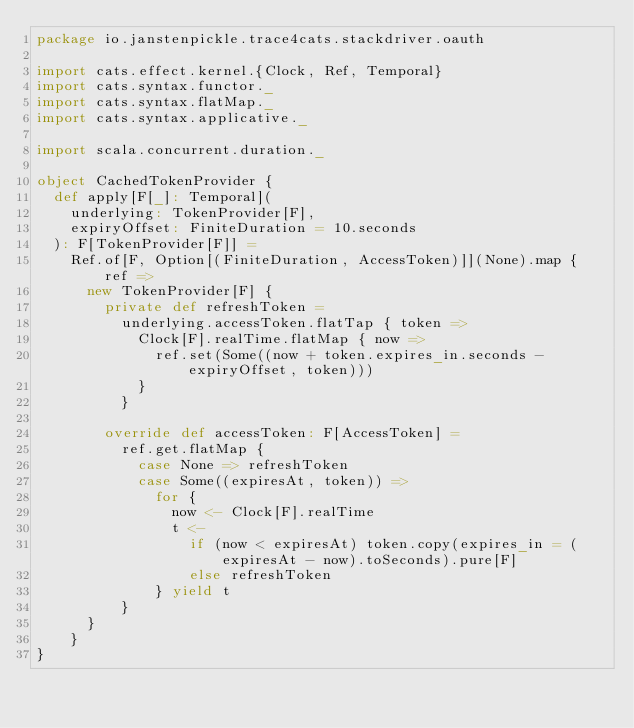<code> <loc_0><loc_0><loc_500><loc_500><_Scala_>package io.janstenpickle.trace4cats.stackdriver.oauth

import cats.effect.kernel.{Clock, Ref, Temporal}
import cats.syntax.functor._
import cats.syntax.flatMap._
import cats.syntax.applicative._

import scala.concurrent.duration._

object CachedTokenProvider {
  def apply[F[_]: Temporal](
    underlying: TokenProvider[F],
    expiryOffset: FiniteDuration = 10.seconds
  ): F[TokenProvider[F]] =
    Ref.of[F, Option[(FiniteDuration, AccessToken)]](None).map { ref =>
      new TokenProvider[F] {
        private def refreshToken =
          underlying.accessToken.flatTap { token =>
            Clock[F].realTime.flatMap { now =>
              ref.set(Some((now + token.expires_in.seconds - expiryOffset, token)))
            }
          }

        override def accessToken: F[AccessToken] =
          ref.get.flatMap {
            case None => refreshToken
            case Some((expiresAt, token)) =>
              for {
                now <- Clock[F].realTime
                t <-
                  if (now < expiresAt) token.copy(expires_in = (expiresAt - now).toSeconds).pure[F]
                  else refreshToken
              } yield t
          }
      }
    }
}
</code> 